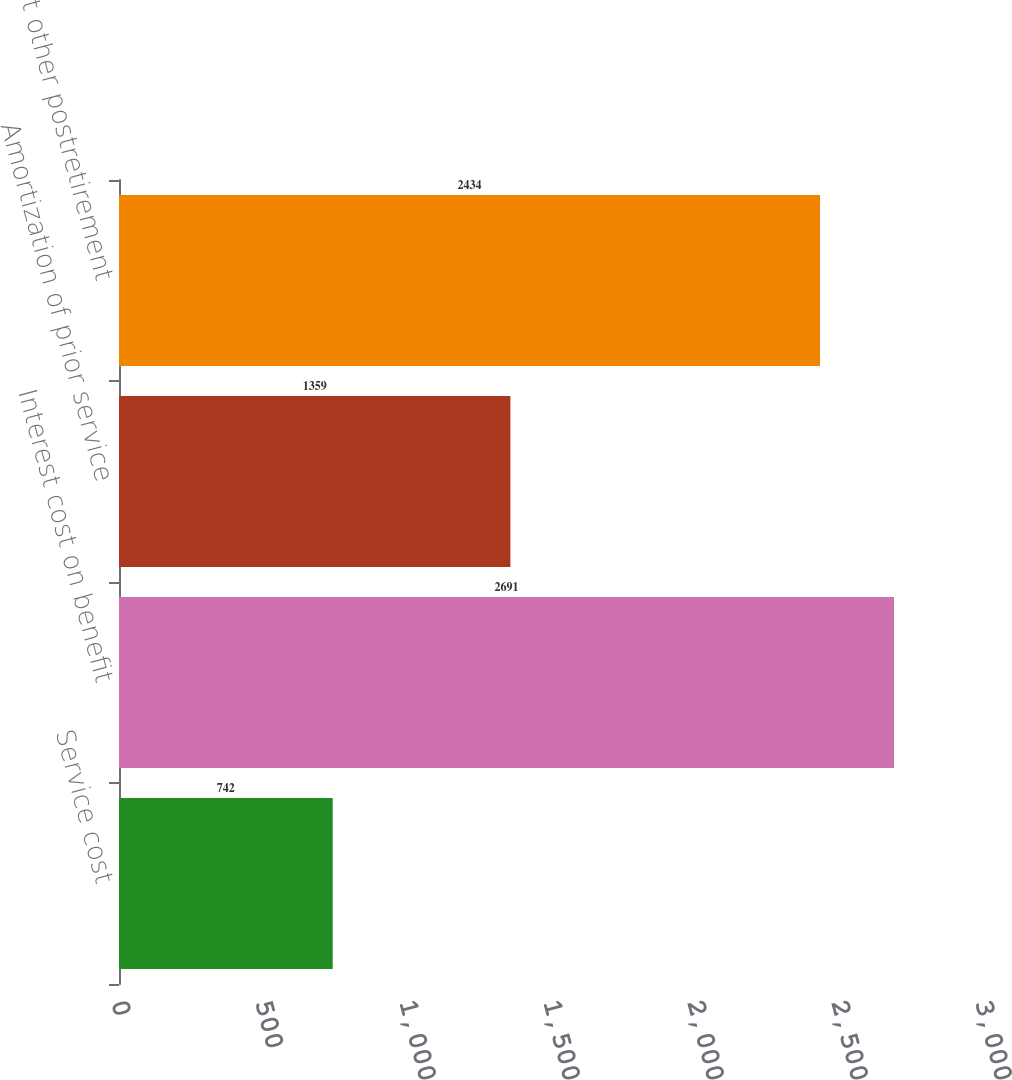<chart> <loc_0><loc_0><loc_500><loc_500><bar_chart><fcel>Service cost<fcel>Interest cost on benefit<fcel>Amortization of prior service<fcel>Net other postretirement<nl><fcel>742<fcel>2691<fcel>1359<fcel>2434<nl></chart> 